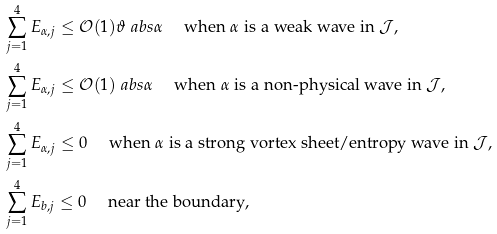<formula> <loc_0><loc_0><loc_500><loc_500>& \sum _ { j = 1 } ^ { 4 } E _ { \alpha , j } \leq \mathcal { O } ( 1 ) \vartheta \ a b s { \alpha } \quad \text { when $\alpha$ is a weak wave in $\mathcal{J}$} , \\ & \sum _ { j = 1 } ^ { 4 } E _ { \alpha , j } \leq \mathcal { O } ( 1 ) \ a b s { \alpha } \quad \text { when $\alpha$ is a non-physical wave in $\mathcal{J}$,} \\ & \sum _ { j = 1 } ^ { 4 } E _ { \alpha , j } \leq 0 \quad \text { when $\alpha$ is a strong vortex sheet/entropy wave in $\mathcal{J}$,} \\ & \sum _ { j = 1 } ^ { 4 } E _ { b , j } \leq 0 \quad \text { near the boundary} ,</formula> 